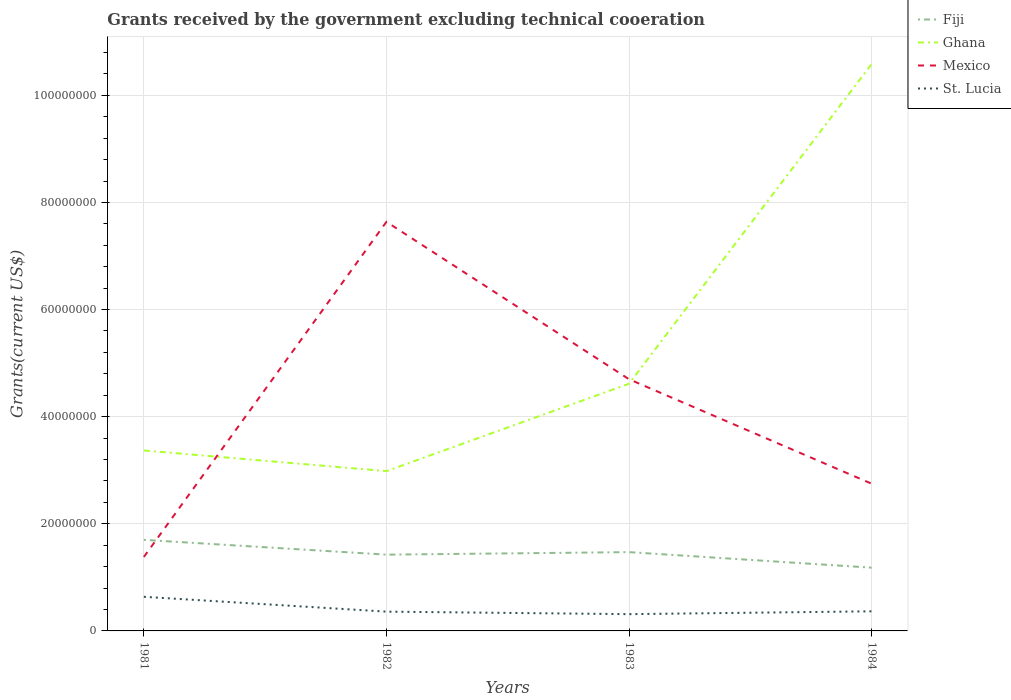Does the line corresponding to Ghana intersect with the line corresponding to Mexico?
Make the answer very short. Yes. Is the number of lines equal to the number of legend labels?
Provide a short and direct response. Yes. Across all years, what is the maximum total grants received by the government in St. Lucia?
Offer a very short reply. 3.13e+06. In which year was the total grants received by the government in St. Lucia maximum?
Provide a short and direct response. 1983. What is the total total grants received by the government in Fiji in the graph?
Keep it short and to the point. 2.90e+06. What is the difference between the highest and the second highest total grants received by the government in Fiji?
Offer a very short reply. 5.19e+06. How many lines are there?
Ensure brevity in your answer.  4. How many years are there in the graph?
Keep it short and to the point. 4. Are the values on the major ticks of Y-axis written in scientific E-notation?
Your answer should be compact. No. Does the graph contain any zero values?
Make the answer very short. No. Where does the legend appear in the graph?
Your answer should be compact. Top right. How many legend labels are there?
Ensure brevity in your answer.  4. What is the title of the graph?
Provide a succinct answer. Grants received by the government excluding technical cooeration. What is the label or title of the X-axis?
Your answer should be very brief. Years. What is the label or title of the Y-axis?
Give a very brief answer. Grants(current US$). What is the Grants(current US$) in Fiji in 1981?
Ensure brevity in your answer.  1.70e+07. What is the Grants(current US$) of Ghana in 1981?
Ensure brevity in your answer.  3.37e+07. What is the Grants(current US$) of Mexico in 1981?
Provide a short and direct response. 1.38e+07. What is the Grants(current US$) in St. Lucia in 1981?
Offer a very short reply. 6.37e+06. What is the Grants(current US$) in Fiji in 1982?
Provide a succinct answer. 1.42e+07. What is the Grants(current US$) of Ghana in 1982?
Offer a very short reply. 2.98e+07. What is the Grants(current US$) of Mexico in 1982?
Offer a very short reply. 7.64e+07. What is the Grants(current US$) of St. Lucia in 1982?
Your answer should be compact. 3.60e+06. What is the Grants(current US$) in Fiji in 1983?
Your answer should be compact. 1.47e+07. What is the Grants(current US$) in Ghana in 1983?
Offer a very short reply. 4.62e+07. What is the Grants(current US$) in Mexico in 1983?
Offer a very short reply. 4.70e+07. What is the Grants(current US$) in St. Lucia in 1983?
Provide a succinct answer. 3.13e+06. What is the Grants(current US$) of Fiji in 1984?
Give a very brief answer. 1.18e+07. What is the Grants(current US$) in Ghana in 1984?
Make the answer very short. 1.06e+08. What is the Grants(current US$) of Mexico in 1984?
Make the answer very short. 2.75e+07. What is the Grants(current US$) of St. Lucia in 1984?
Make the answer very short. 3.66e+06. Across all years, what is the maximum Grants(current US$) in Fiji?
Provide a succinct answer. 1.70e+07. Across all years, what is the maximum Grants(current US$) in Ghana?
Make the answer very short. 1.06e+08. Across all years, what is the maximum Grants(current US$) in Mexico?
Make the answer very short. 7.64e+07. Across all years, what is the maximum Grants(current US$) in St. Lucia?
Offer a very short reply. 6.37e+06. Across all years, what is the minimum Grants(current US$) in Fiji?
Ensure brevity in your answer.  1.18e+07. Across all years, what is the minimum Grants(current US$) of Ghana?
Your answer should be very brief. 2.98e+07. Across all years, what is the minimum Grants(current US$) of Mexico?
Ensure brevity in your answer.  1.38e+07. Across all years, what is the minimum Grants(current US$) of St. Lucia?
Your response must be concise. 3.13e+06. What is the total Grants(current US$) in Fiji in the graph?
Offer a very short reply. 5.78e+07. What is the total Grants(current US$) in Ghana in the graph?
Give a very brief answer. 2.16e+08. What is the total Grants(current US$) in Mexico in the graph?
Keep it short and to the point. 1.65e+08. What is the total Grants(current US$) of St. Lucia in the graph?
Give a very brief answer. 1.68e+07. What is the difference between the Grants(current US$) in Fiji in 1981 and that in 1982?
Offer a very short reply. 2.76e+06. What is the difference between the Grants(current US$) in Ghana in 1981 and that in 1982?
Offer a very short reply. 3.86e+06. What is the difference between the Grants(current US$) in Mexico in 1981 and that in 1982?
Ensure brevity in your answer.  -6.26e+07. What is the difference between the Grants(current US$) of St. Lucia in 1981 and that in 1982?
Your answer should be compact. 2.77e+06. What is the difference between the Grants(current US$) of Fiji in 1981 and that in 1983?
Your answer should be compact. 2.29e+06. What is the difference between the Grants(current US$) in Ghana in 1981 and that in 1983?
Provide a succinct answer. -1.25e+07. What is the difference between the Grants(current US$) in Mexico in 1981 and that in 1983?
Your answer should be very brief. -3.32e+07. What is the difference between the Grants(current US$) of St. Lucia in 1981 and that in 1983?
Ensure brevity in your answer.  3.24e+06. What is the difference between the Grants(current US$) in Fiji in 1981 and that in 1984?
Your response must be concise. 5.19e+06. What is the difference between the Grants(current US$) of Ghana in 1981 and that in 1984?
Ensure brevity in your answer.  -7.21e+07. What is the difference between the Grants(current US$) in Mexico in 1981 and that in 1984?
Make the answer very short. -1.37e+07. What is the difference between the Grants(current US$) of St. Lucia in 1981 and that in 1984?
Keep it short and to the point. 2.71e+06. What is the difference between the Grants(current US$) of Fiji in 1982 and that in 1983?
Give a very brief answer. -4.70e+05. What is the difference between the Grants(current US$) in Ghana in 1982 and that in 1983?
Your answer should be very brief. -1.63e+07. What is the difference between the Grants(current US$) of Mexico in 1982 and that in 1983?
Keep it short and to the point. 2.94e+07. What is the difference between the Grants(current US$) in St. Lucia in 1982 and that in 1983?
Make the answer very short. 4.70e+05. What is the difference between the Grants(current US$) of Fiji in 1982 and that in 1984?
Ensure brevity in your answer.  2.43e+06. What is the difference between the Grants(current US$) in Ghana in 1982 and that in 1984?
Ensure brevity in your answer.  -7.60e+07. What is the difference between the Grants(current US$) in Mexico in 1982 and that in 1984?
Your answer should be very brief. 4.89e+07. What is the difference between the Grants(current US$) in Fiji in 1983 and that in 1984?
Give a very brief answer. 2.90e+06. What is the difference between the Grants(current US$) in Ghana in 1983 and that in 1984?
Your response must be concise. -5.97e+07. What is the difference between the Grants(current US$) in Mexico in 1983 and that in 1984?
Offer a terse response. 1.95e+07. What is the difference between the Grants(current US$) in St. Lucia in 1983 and that in 1984?
Keep it short and to the point. -5.30e+05. What is the difference between the Grants(current US$) in Fiji in 1981 and the Grants(current US$) in Ghana in 1982?
Offer a terse response. -1.28e+07. What is the difference between the Grants(current US$) of Fiji in 1981 and the Grants(current US$) of Mexico in 1982?
Provide a succinct answer. -5.94e+07. What is the difference between the Grants(current US$) in Fiji in 1981 and the Grants(current US$) in St. Lucia in 1982?
Offer a very short reply. 1.34e+07. What is the difference between the Grants(current US$) in Ghana in 1981 and the Grants(current US$) in Mexico in 1982?
Give a very brief answer. -4.27e+07. What is the difference between the Grants(current US$) in Ghana in 1981 and the Grants(current US$) in St. Lucia in 1982?
Provide a short and direct response. 3.01e+07. What is the difference between the Grants(current US$) of Mexico in 1981 and the Grants(current US$) of St. Lucia in 1982?
Keep it short and to the point. 1.02e+07. What is the difference between the Grants(current US$) of Fiji in 1981 and the Grants(current US$) of Ghana in 1983?
Your answer should be compact. -2.92e+07. What is the difference between the Grants(current US$) of Fiji in 1981 and the Grants(current US$) of Mexico in 1983?
Provide a succinct answer. -3.00e+07. What is the difference between the Grants(current US$) in Fiji in 1981 and the Grants(current US$) in St. Lucia in 1983?
Give a very brief answer. 1.39e+07. What is the difference between the Grants(current US$) of Ghana in 1981 and the Grants(current US$) of Mexico in 1983?
Offer a terse response. -1.33e+07. What is the difference between the Grants(current US$) in Ghana in 1981 and the Grants(current US$) in St. Lucia in 1983?
Give a very brief answer. 3.06e+07. What is the difference between the Grants(current US$) in Mexico in 1981 and the Grants(current US$) in St. Lucia in 1983?
Make the answer very short. 1.07e+07. What is the difference between the Grants(current US$) in Fiji in 1981 and the Grants(current US$) in Ghana in 1984?
Keep it short and to the point. -8.88e+07. What is the difference between the Grants(current US$) of Fiji in 1981 and the Grants(current US$) of Mexico in 1984?
Your response must be concise. -1.05e+07. What is the difference between the Grants(current US$) in Fiji in 1981 and the Grants(current US$) in St. Lucia in 1984?
Keep it short and to the point. 1.33e+07. What is the difference between the Grants(current US$) in Ghana in 1981 and the Grants(current US$) in Mexico in 1984?
Keep it short and to the point. 6.20e+06. What is the difference between the Grants(current US$) in Ghana in 1981 and the Grants(current US$) in St. Lucia in 1984?
Your response must be concise. 3.00e+07. What is the difference between the Grants(current US$) in Mexico in 1981 and the Grants(current US$) in St. Lucia in 1984?
Ensure brevity in your answer.  1.02e+07. What is the difference between the Grants(current US$) of Fiji in 1982 and the Grants(current US$) of Ghana in 1983?
Provide a short and direct response. -3.19e+07. What is the difference between the Grants(current US$) of Fiji in 1982 and the Grants(current US$) of Mexico in 1983?
Offer a very short reply. -3.28e+07. What is the difference between the Grants(current US$) in Fiji in 1982 and the Grants(current US$) in St. Lucia in 1983?
Offer a very short reply. 1.11e+07. What is the difference between the Grants(current US$) in Ghana in 1982 and the Grants(current US$) in Mexico in 1983?
Ensure brevity in your answer.  -1.72e+07. What is the difference between the Grants(current US$) of Ghana in 1982 and the Grants(current US$) of St. Lucia in 1983?
Your response must be concise. 2.67e+07. What is the difference between the Grants(current US$) of Mexico in 1982 and the Grants(current US$) of St. Lucia in 1983?
Ensure brevity in your answer.  7.32e+07. What is the difference between the Grants(current US$) in Fiji in 1982 and the Grants(current US$) in Ghana in 1984?
Your answer should be very brief. -9.16e+07. What is the difference between the Grants(current US$) in Fiji in 1982 and the Grants(current US$) in Mexico in 1984?
Ensure brevity in your answer.  -1.32e+07. What is the difference between the Grants(current US$) in Fiji in 1982 and the Grants(current US$) in St. Lucia in 1984?
Provide a succinct answer. 1.06e+07. What is the difference between the Grants(current US$) of Ghana in 1982 and the Grants(current US$) of Mexico in 1984?
Make the answer very short. 2.34e+06. What is the difference between the Grants(current US$) in Ghana in 1982 and the Grants(current US$) in St. Lucia in 1984?
Offer a terse response. 2.62e+07. What is the difference between the Grants(current US$) in Mexico in 1982 and the Grants(current US$) in St. Lucia in 1984?
Make the answer very short. 7.27e+07. What is the difference between the Grants(current US$) in Fiji in 1983 and the Grants(current US$) in Ghana in 1984?
Offer a very short reply. -9.11e+07. What is the difference between the Grants(current US$) in Fiji in 1983 and the Grants(current US$) in Mexico in 1984?
Keep it short and to the point. -1.28e+07. What is the difference between the Grants(current US$) of Fiji in 1983 and the Grants(current US$) of St. Lucia in 1984?
Provide a succinct answer. 1.10e+07. What is the difference between the Grants(current US$) of Ghana in 1983 and the Grants(current US$) of Mexico in 1984?
Ensure brevity in your answer.  1.87e+07. What is the difference between the Grants(current US$) of Ghana in 1983 and the Grants(current US$) of St. Lucia in 1984?
Ensure brevity in your answer.  4.25e+07. What is the difference between the Grants(current US$) of Mexico in 1983 and the Grants(current US$) of St. Lucia in 1984?
Provide a succinct answer. 4.33e+07. What is the average Grants(current US$) in Fiji per year?
Your answer should be compact. 1.44e+07. What is the average Grants(current US$) of Ghana per year?
Offer a very short reply. 5.39e+07. What is the average Grants(current US$) in Mexico per year?
Your answer should be very brief. 4.12e+07. What is the average Grants(current US$) of St. Lucia per year?
Your response must be concise. 4.19e+06. In the year 1981, what is the difference between the Grants(current US$) of Fiji and Grants(current US$) of Ghana?
Give a very brief answer. -1.67e+07. In the year 1981, what is the difference between the Grants(current US$) of Fiji and Grants(current US$) of Mexico?
Your answer should be compact. 3.19e+06. In the year 1981, what is the difference between the Grants(current US$) of Fiji and Grants(current US$) of St. Lucia?
Give a very brief answer. 1.06e+07. In the year 1981, what is the difference between the Grants(current US$) in Ghana and Grants(current US$) in Mexico?
Keep it short and to the point. 1.99e+07. In the year 1981, what is the difference between the Grants(current US$) in Ghana and Grants(current US$) in St. Lucia?
Offer a very short reply. 2.73e+07. In the year 1981, what is the difference between the Grants(current US$) in Mexico and Grants(current US$) in St. Lucia?
Your response must be concise. 7.44e+06. In the year 1982, what is the difference between the Grants(current US$) in Fiji and Grants(current US$) in Ghana?
Provide a succinct answer. -1.56e+07. In the year 1982, what is the difference between the Grants(current US$) of Fiji and Grants(current US$) of Mexico?
Offer a terse response. -6.21e+07. In the year 1982, what is the difference between the Grants(current US$) in Fiji and Grants(current US$) in St. Lucia?
Your answer should be very brief. 1.06e+07. In the year 1982, what is the difference between the Grants(current US$) of Ghana and Grants(current US$) of Mexico?
Give a very brief answer. -4.66e+07. In the year 1982, what is the difference between the Grants(current US$) of Ghana and Grants(current US$) of St. Lucia?
Make the answer very short. 2.62e+07. In the year 1982, what is the difference between the Grants(current US$) in Mexico and Grants(current US$) in St. Lucia?
Offer a terse response. 7.28e+07. In the year 1983, what is the difference between the Grants(current US$) in Fiji and Grants(current US$) in Ghana?
Provide a short and direct response. -3.14e+07. In the year 1983, what is the difference between the Grants(current US$) in Fiji and Grants(current US$) in Mexico?
Ensure brevity in your answer.  -3.23e+07. In the year 1983, what is the difference between the Grants(current US$) in Fiji and Grants(current US$) in St. Lucia?
Keep it short and to the point. 1.16e+07. In the year 1983, what is the difference between the Grants(current US$) in Ghana and Grants(current US$) in Mexico?
Give a very brief answer. -8.40e+05. In the year 1983, what is the difference between the Grants(current US$) in Ghana and Grants(current US$) in St. Lucia?
Offer a very short reply. 4.30e+07. In the year 1983, what is the difference between the Grants(current US$) in Mexico and Grants(current US$) in St. Lucia?
Offer a very short reply. 4.39e+07. In the year 1984, what is the difference between the Grants(current US$) of Fiji and Grants(current US$) of Ghana?
Ensure brevity in your answer.  -9.40e+07. In the year 1984, what is the difference between the Grants(current US$) in Fiji and Grants(current US$) in Mexico?
Provide a succinct answer. -1.57e+07. In the year 1984, what is the difference between the Grants(current US$) of Fiji and Grants(current US$) of St. Lucia?
Your answer should be compact. 8.15e+06. In the year 1984, what is the difference between the Grants(current US$) of Ghana and Grants(current US$) of Mexico?
Give a very brief answer. 7.83e+07. In the year 1984, what is the difference between the Grants(current US$) in Ghana and Grants(current US$) in St. Lucia?
Provide a short and direct response. 1.02e+08. In the year 1984, what is the difference between the Grants(current US$) of Mexico and Grants(current US$) of St. Lucia?
Give a very brief answer. 2.38e+07. What is the ratio of the Grants(current US$) of Fiji in 1981 to that in 1982?
Ensure brevity in your answer.  1.19. What is the ratio of the Grants(current US$) in Ghana in 1981 to that in 1982?
Provide a short and direct response. 1.13. What is the ratio of the Grants(current US$) of Mexico in 1981 to that in 1982?
Provide a short and direct response. 0.18. What is the ratio of the Grants(current US$) of St. Lucia in 1981 to that in 1982?
Make the answer very short. 1.77. What is the ratio of the Grants(current US$) of Fiji in 1981 to that in 1983?
Provide a succinct answer. 1.16. What is the ratio of the Grants(current US$) in Ghana in 1981 to that in 1983?
Offer a very short reply. 0.73. What is the ratio of the Grants(current US$) in Mexico in 1981 to that in 1983?
Ensure brevity in your answer.  0.29. What is the ratio of the Grants(current US$) of St. Lucia in 1981 to that in 1983?
Your answer should be compact. 2.04. What is the ratio of the Grants(current US$) of Fiji in 1981 to that in 1984?
Ensure brevity in your answer.  1.44. What is the ratio of the Grants(current US$) of Ghana in 1981 to that in 1984?
Give a very brief answer. 0.32. What is the ratio of the Grants(current US$) of Mexico in 1981 to that in 1984?
Give a very brief answer. 0.5. What is the ratio of the Grants(current US$) in St. Lucia in 1981 to that in 1984?
Provide a short and direct response. 1.74. What is the ratio of the Grants(current US$) in Ghana in 1982 to that in 1983?
Offer a very short reply. 0.65. What is the ratio of the Grants(current US$) in Mexico in 1982 to that in 1983?
Provide a short and direct response. 1.63. What is the ratio of the Grants(current US$) in St. Lucia in 1982 to that in 1983?
Your response must be concise. 1.15. What is the ratio of the Grants(current US$) in Fiji in 1982 to that in 1984?
Your answer should be very brief. 1.21. What is the ratio of the Grants(current US$) of Ghana in 1982 to that in 1984?
Your answer should be very brief. 0.28. What is the ratio of the Grants(current US$) in Mexico in 1982 to that in 1984?
Give a very brief answer. 2.78. What is the ratio of the Grants(current US$) in St. Lucia in 1982 to that in 1984?
Offer a very short reply. 0.98. What is the ratio of the Grants(current US$) of Fiji in 1983 to that in 1984?
Offer a terse response. 1.25. What is the ratio of the Grants(current US$) of Ghana in 1983 to that in 1984?
Keep it short and to the point. 0.44. What is the ratio of the Grants(current US$) of Mexico in 1983 to that in 1984?
Your answer should be compact. 1.71. What is the ratio of the Grants(current US$) in St. Lucia in 1983 to that in 1984?
Make the answer very short. 0.86. What is the difference between the highest and the second highest Grants(current US$) in Fiji?
Provide a succinct answer. 2.29e+06. What is the difference between the highest and the second highest Grants(current US$) in Ghana?
Provide a short and direct response. 5.97e+07. What is the difference between the highest and the second highest Grants(current US$) of Mexico?
Provide a short and direct response. 2.94e+07. What is the difference between the highest and the second highest Grants(current US$) in St. Lucia?
Keep it short and to the point. 2.71e+06. What is the difference between the highest and the lowest Grants(current US$) of Fiji?
Your answer should be very brief. 5.19e+06. What is the difference between the highest and the lowest Grants(current US$) of Ghana?
Offer a terse response. 7.60e+07. What is the difference between the highest and the lowest Grants(current US$) in Mexico?
Provide a short and direct response. 6.26e+07. What is the difference between the highest and the lowest Grants(current US$) in St. Lucia?
Provide a short and direct response. 3.24e+06. 